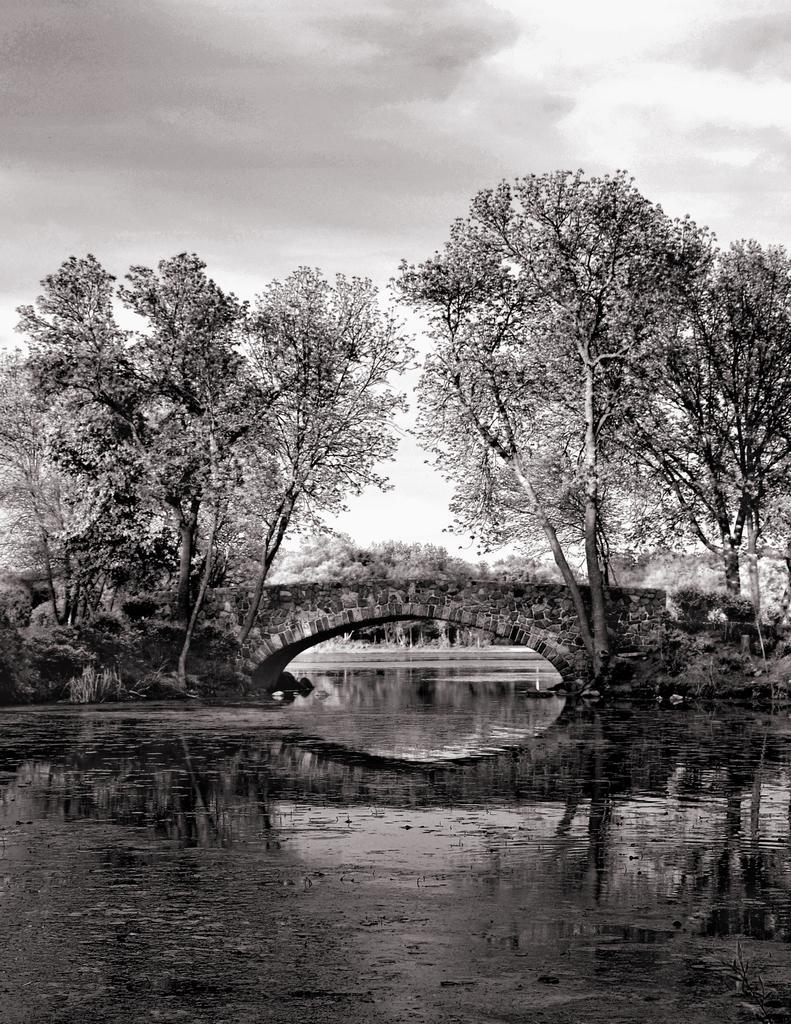How would you summarize this image in a sentence or two? Here in this picture in the front we can see water present over a place and in the middle we can see a bridge and below that we can see a tunnel present and we can also see plants and trees present on the ground and we can see the sky is fully covered with clouds. 